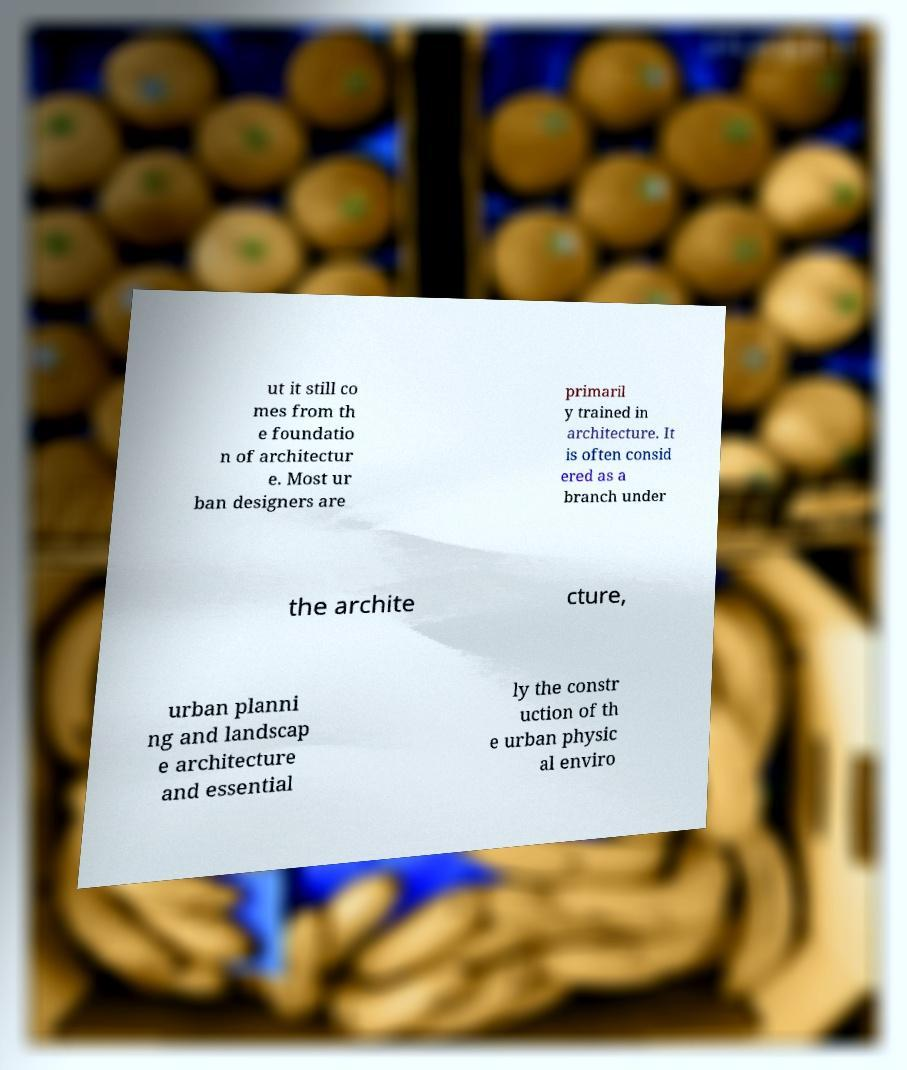Could you assist in decoding the text presented in this image and type it out clearly? ut it still co mes from th e foundatio n of architectur e. Most ur ban designers are primaril y trained in architecture. It is often consid ered as a branch under the archite cture, urban planni ng and landscap e architecture and essential ly the constr uction of th e urban physic al enviro 